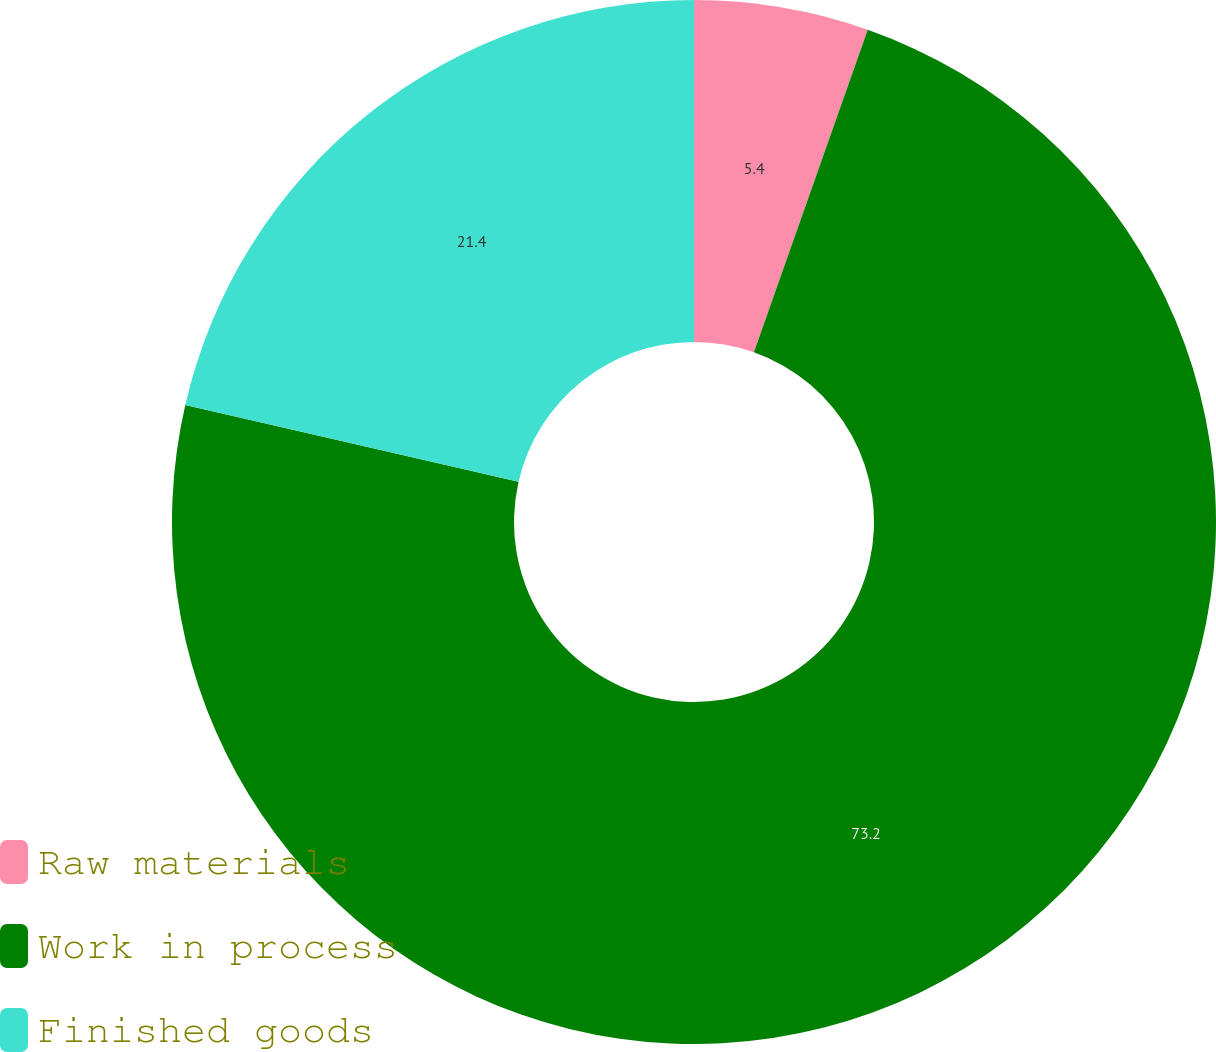Convert chart. <chart><loc_0><loc_0><loc_500><loc_500><pie_chart><fcel>Raw materials<fcel>Work in process<fcel>Finished goods<nl><fcel>5.4%<fcel>73.2%<fcel>21.4%<nl></chart> 